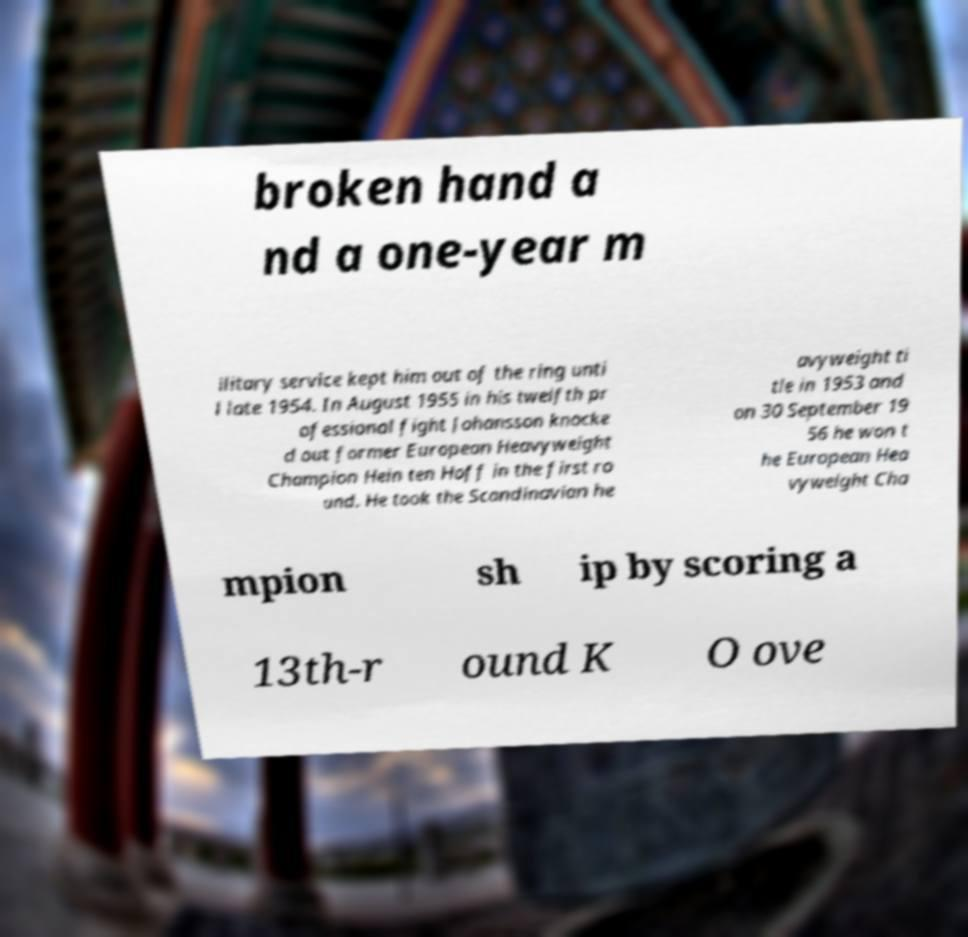There's text embedded in this image that I need extracted. Can you transcribe it verbatim? broken hand a nd a one-year m ilitary service kept him out of the ring unti l late 1954. In August 1955 in his twelfth pr ofessional fight Johansson knocke d out former European Heavyweight Champion Hein ten Hoff in the first ro und. He took the Scandinavian he avyweight ti tle in 1953 and on 30 September 19 56 he won t he European Hea vyweight Cha mpion sh ip by scoring a 13th-r ound K O ove 